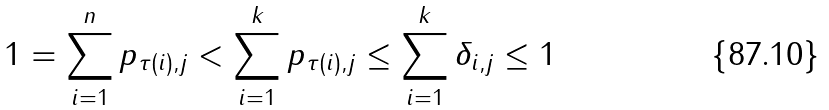<formula> <loc_0><loc_0><loc_500><loc_500>1 = \sum _ { i = 1 } ^ { n } p _ { \tau ( i ) , j } < \sum _ { i = 1 } ^ { k } p _ { \tau ( i ) , j } \leq \sum _ { i = 1 } ^ { k } \delta _ { i , j } \leq 1</formula> 